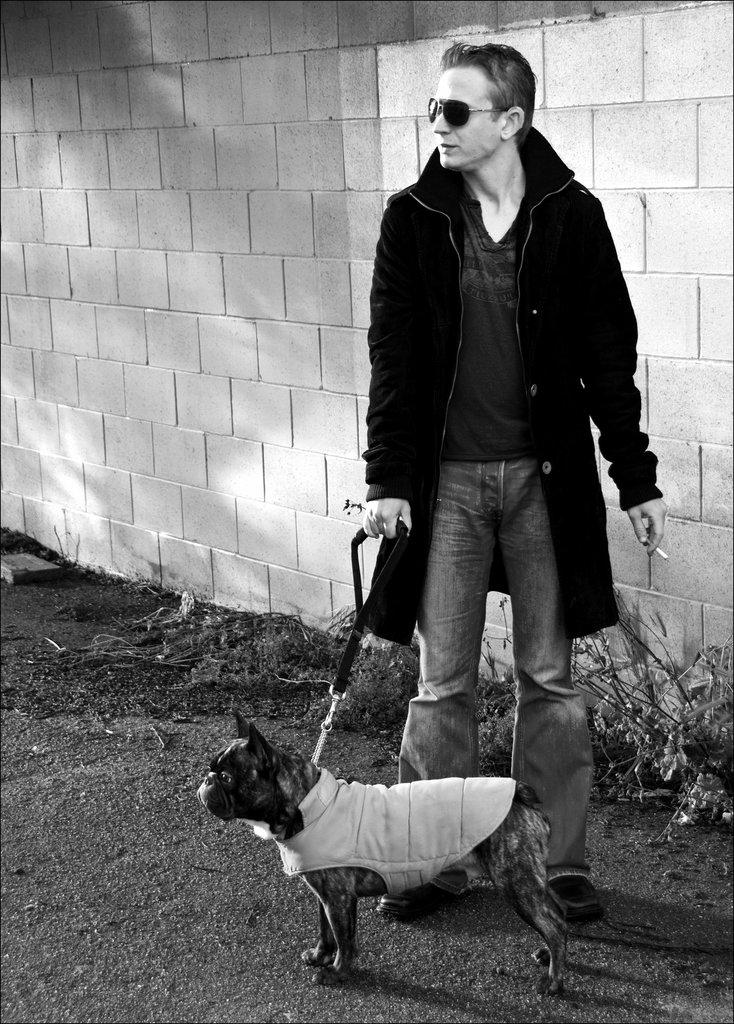What is the color scheme of the image? The image is black and white. Who is present in the image? There is a man in the image. What is the man wearing? The man is wearing a black jacket. What is the man holding in the image? The man is holding a cigarette and a dog belt. What else can be seen in the image? There is a dog in the image, and the dog is dressed. What is visible in the background of the image? There is a wall in the background of the image. What is the name of the man in the image? The provided facts do not mention the name of the man in the image. How wealthy is the man in the image? The provided facts do not mention the man's wealth or financial status. 